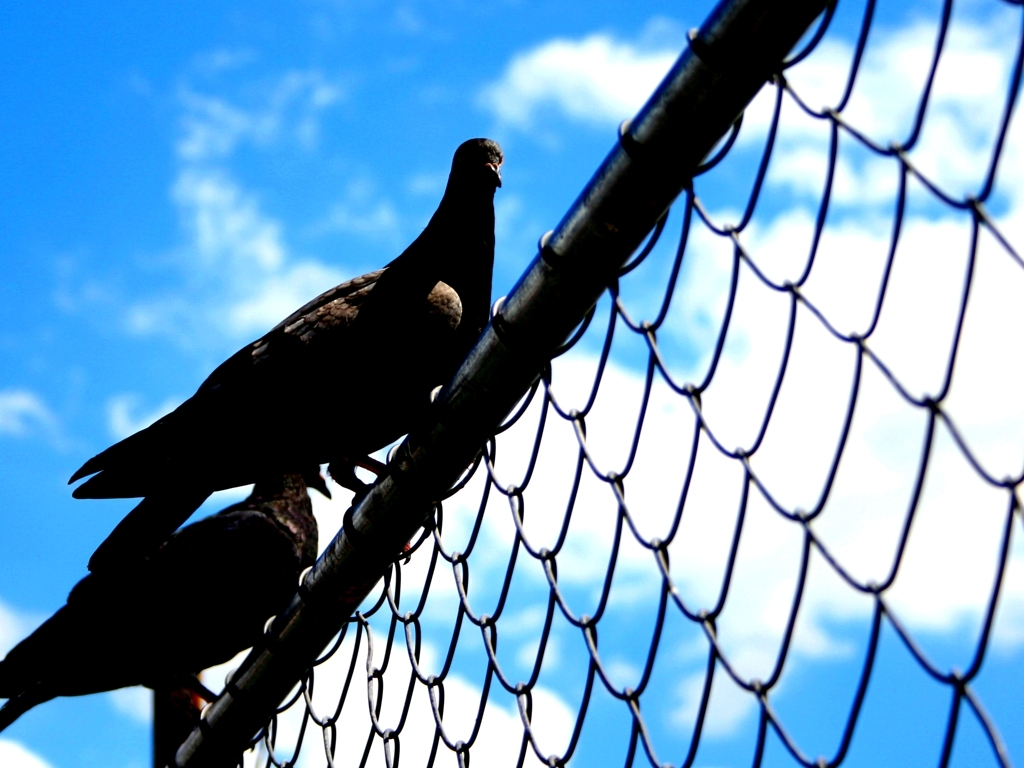Can you explain the significance of the pigeon in this setting? Certainly, pigeons are often found in urban environments where structures like this wire fence are common. In this image, the pigeon perched on the fence may suggest a theme of adaptation, as these birds have learned to thrive in man-made landscapes. The contrast between the natural element of the bird and the industrial aspect of the fence accentuates their coexistence in modern habitats. 